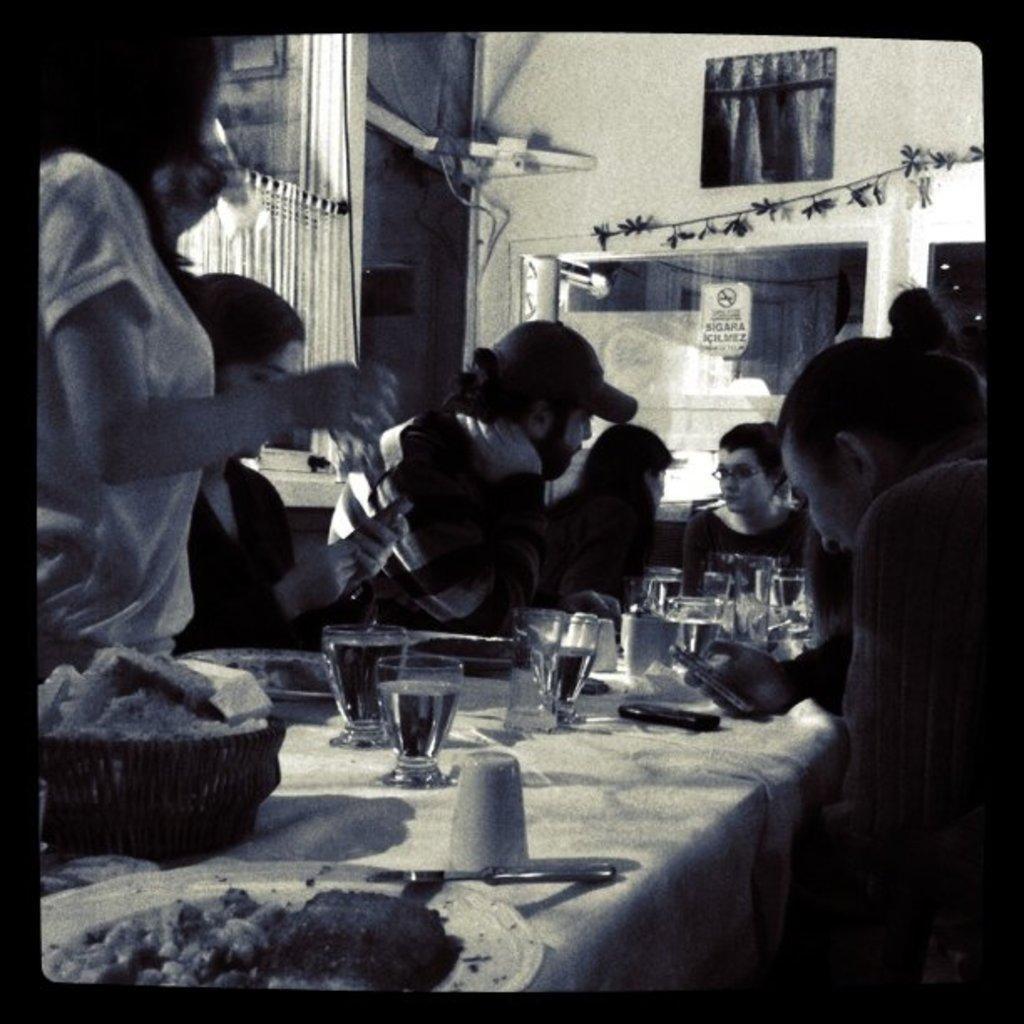How would you summarize this image in a sentence or two? There are many people sitting and standing in this room. In front of them there is a table. On the table there are glasses, plates, forks, knives, food items, plates ,baskets. In the background there is a wall with photo frames. 